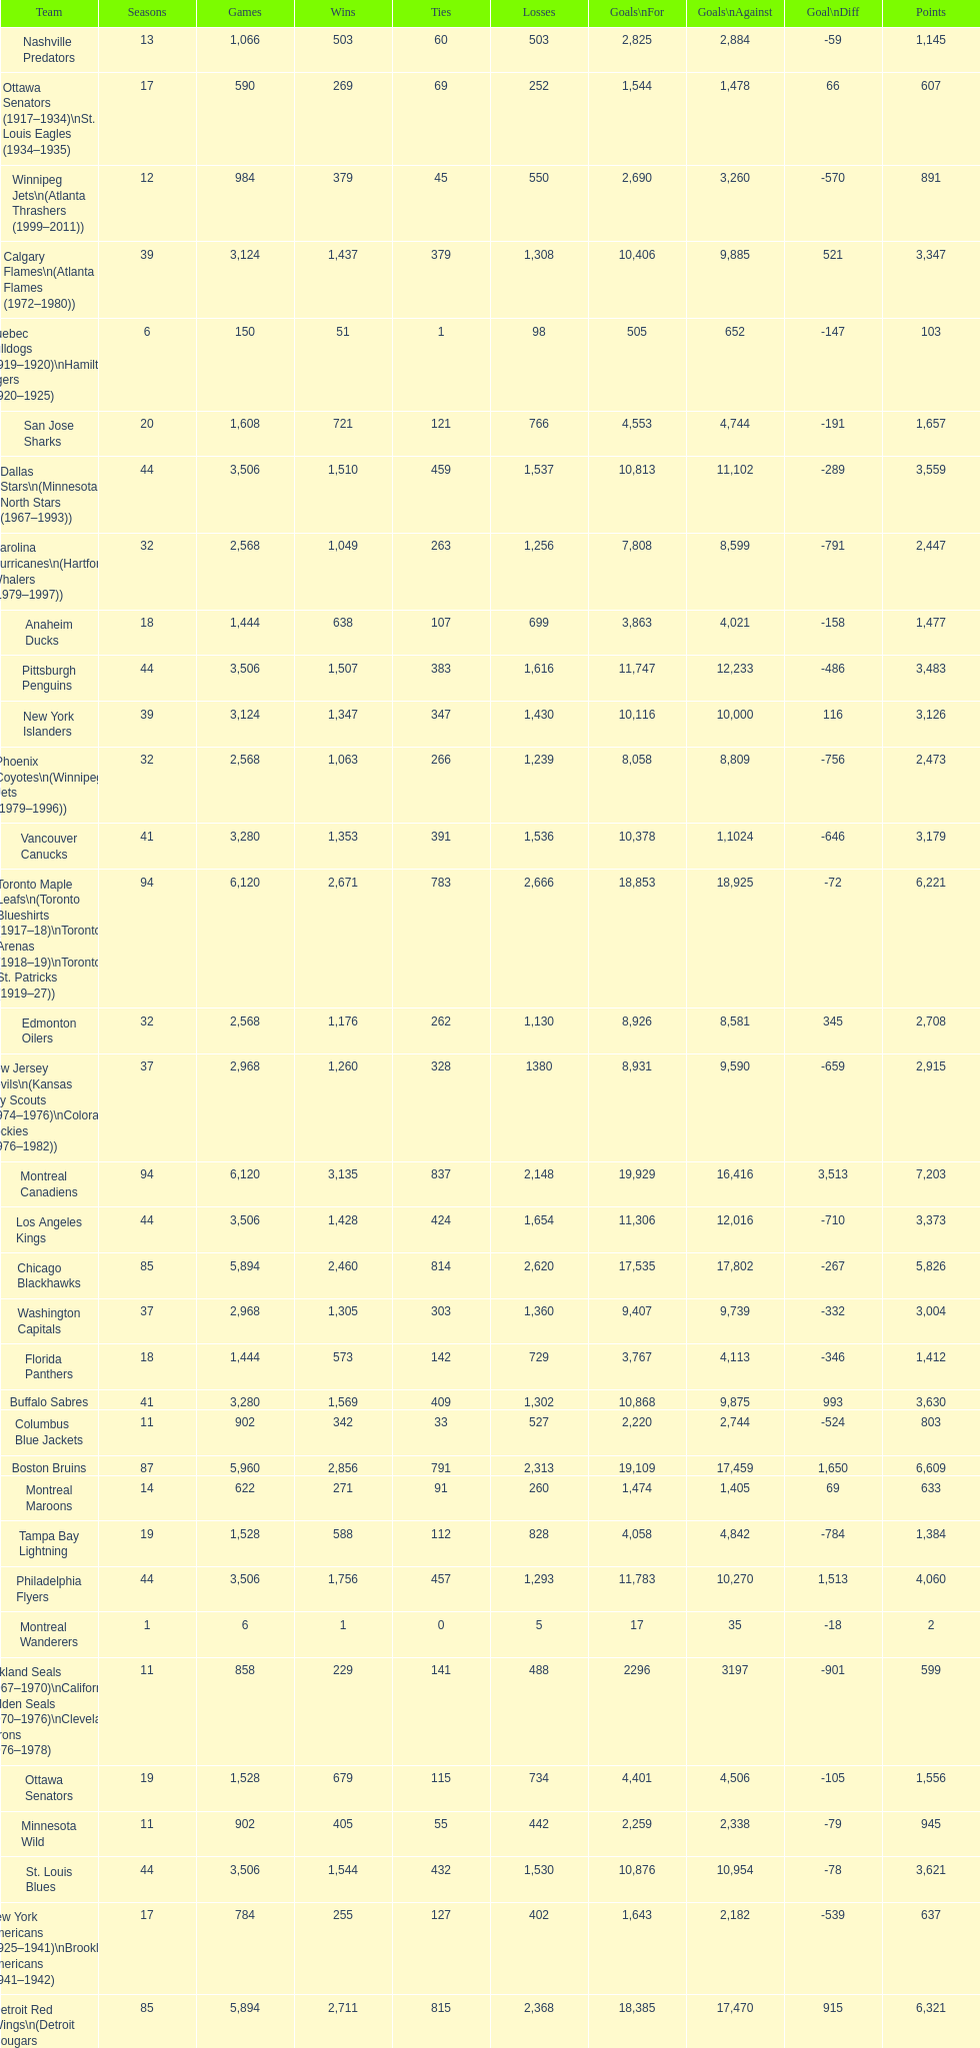What is the total number of points scored by the los angeles kings? 3,373. 